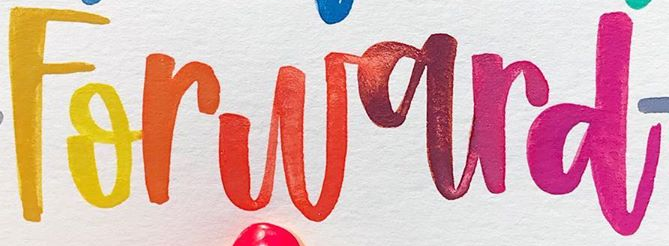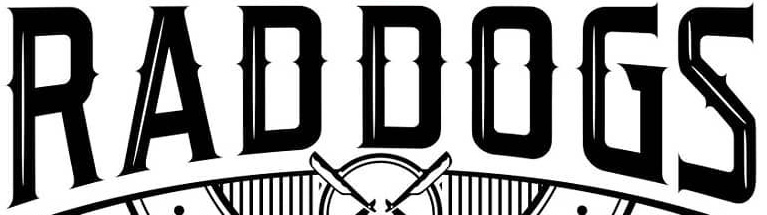Read the text content from these images in order, separated by a semicolon. Forward; RADDOGS 